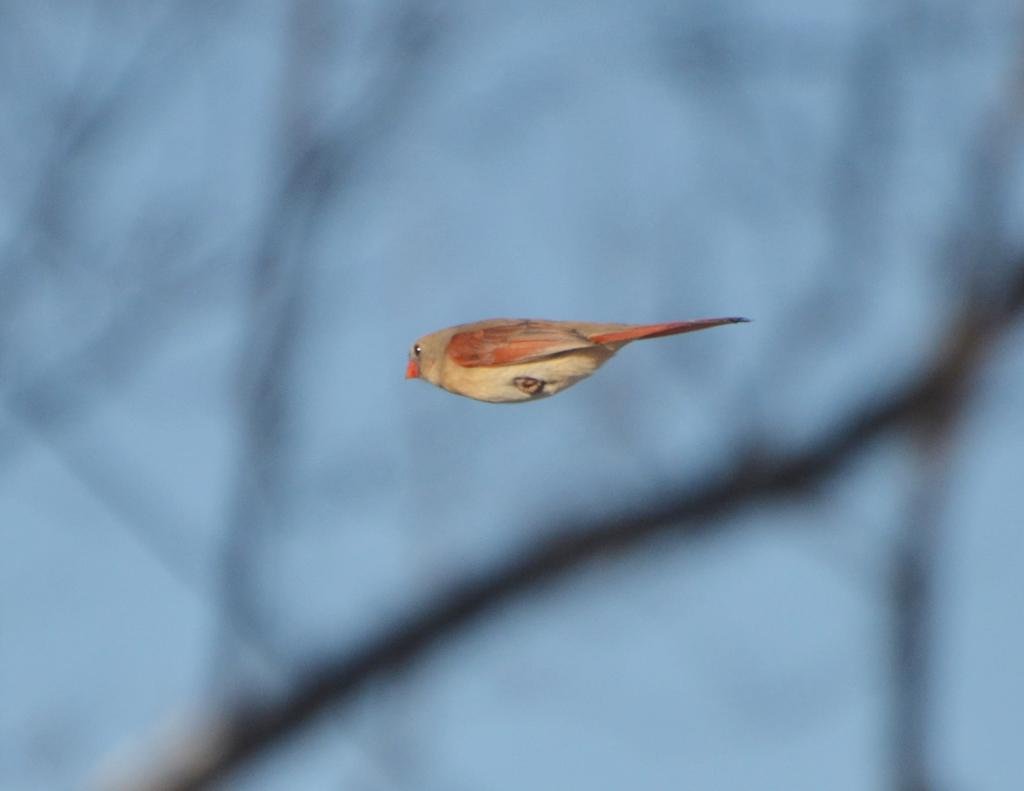What type of animal can be seen in the image? There is a small bird in the image. What color is the sky in the image? The sky in the image is blue. What type of rock is the bird using to express its belief in the image? There is no rock present in the image, and the bird's beliefs are not depicted. 